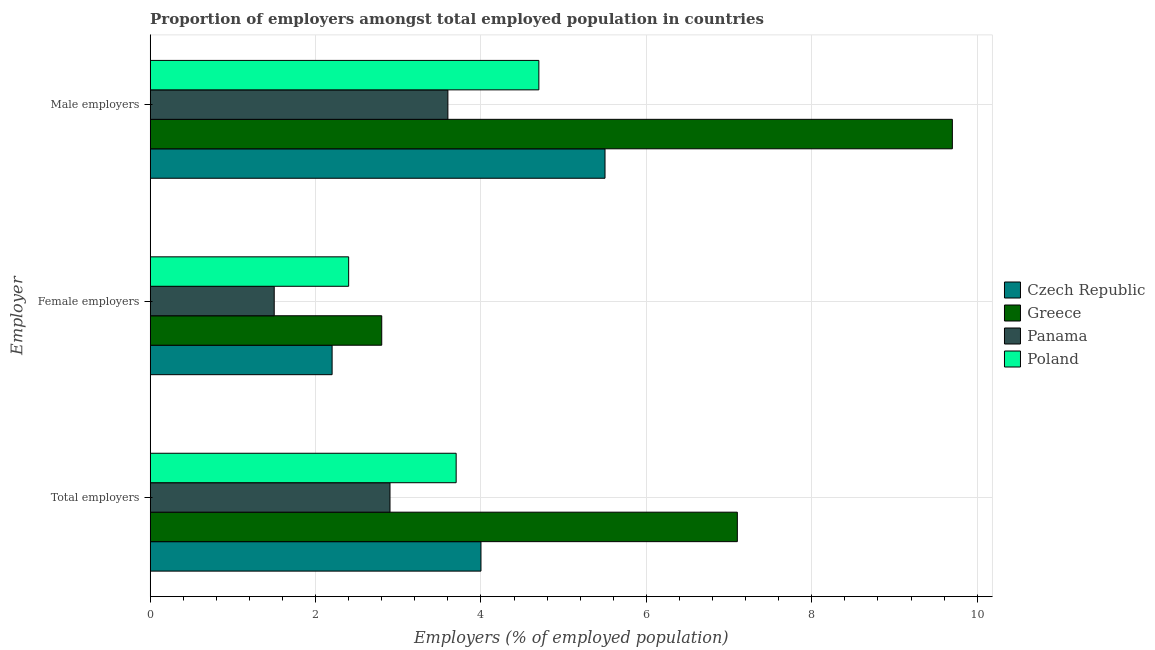How many different coloured bars are there?
Your answer should be compact. 4. How many groups of bars are there?
Make the answer very short. 3. Are the number of bars per tick equal to the number of legend labels?
Keep it short and to the point. Yes. Are the number of bars on each tick of the Y-axis equal?
Give a very brief answer. Yes. How many bars are there on the 3rd tick from the bottom?
Your answer should be very brief. 4. What is the label of the 2nd group of bars from the top?
Make the answer very short. Female employers. What is the percentage of female employers in Czech Republic?
Make the answer very short. 2.2. Across all countries, what is the maximum percentage of female employers?
Give a very brief answer. 2.8. In which country was the percentage of total employers minimum?
Give a very brief answer. Panama. What is the total percentage of total employers in the graph?
Ensure brevity in your answer.  17.7. What is the difference between the percentage of male employers in Greece and that in Czech Republic?
Make the answer very short. 4.2. What is the average percentage of total employers per country?
Keep it short and to the point. 4.43. What is the difference between the percentage of male employers and percentage of female employers in Poland?
Your answer should be compact. 2.3. In how many countries, is the percentage of total employers greater than 5.2 %?
Offer a terse response. 1. What is the ratio of the percentage of female employers in Greece to that in Panama?
Ensure brevity in your answer.  1.87. Is the difference between the percentage of female employers in Czech Republic and Greece greater than the difference between the percentage of total employers in Czech Republic and Greece?
Provide a succinct answer. Yes. What is the difference between the highest and the second highest percentage of female employers?
Keep it short and to the point. 0.4. What is the difference between the highest and the lowest percentage of female employers?
Your response must be concise. 1.3. Is the sum of the percentage of female employers in Poland and Czech Republic greater than the maximum percentage of male employers across all countries?
Provide a short and direct response. No. What does the 4th bar from the top in Total employers represents?
Keep it short and to the point. Czech Republic. What does the 3rd bar from the bottom in Female employers represents?
Your response must be concise. Panama. How many countries are there in the graph?
Your response must be concise. 4. What is the difference between two consecutive major ticks on the X-axis?
Keep it short and to the point. 2. Does the graph contain grids?
Offer a very short reply. Yes. Where does the legend appear in the graph?
Offer a very short reply. Center right. What is the title of the graph?
Offer a terse response. Proportion of employers amongst total employed population in countries. Does "Hong Kong" appear as one of the legend labels in the graph?
Make the answer very short. No. What is the label or title of the X-axis?
Keep it short and to the point. Employers (% of employed population). What is the label or title of the Y-axis?
Give a very brief answer. Employer. What is the Employers (% of employed population) in Greece in Total employers?
Offer a very short reply. 7.1. What is the Employers (% of employed population) in Panama in Total employers?
Your answer should be compact. 2.9. What is the Employers (% of employed population) in Poland in Total employers?
Give a very brief answer. 3.7. What is the Employers (% of employed population) in Czech Republic in Female employers?
Offer a terse response. 2.2. What is the Employers (% of employed population) of Greece in Female employers?
Ensure brevity in your answer.  2.8. What is the Employers (% of employed population) of Panama in Female employers?
Your answer should be very brief. 1.5. What is the Employers (% of employed population) of Poland in Female employers?
Make the answer very short. 2.4. What is the Employers (% of employed population) in Greece in Male employers?
Make the answer very short. 9.7. What is the Employers (% of employed population) of Panama in Male employers?
Your answer should be compact. 3.6. What is the Employers (% of employed population) in Poland in Male employers?
Provide a short and direct response. 4.7. Across all Employer, what is the maximum Employers (% of employed population) in Greece?
Keep it short and to the point. 9.7. Across all Employer, what is the maximum Employers (% of employed population) in Panama?
Offer a terse response. 3.6. Across all Employer, what is the maximum Employers (% of employed population) in Poland?
Give a very brief answer. 4.7. Across all Employer, what is the minimum Employers (% of employed population) in Czech Republic?
Provide a succinct answer. 2.2. Across all Employer, what is the minimum Employers (% of employed population) in Greece?
Your answer should be compact. 2.8. Across all Employer, what is the minimum Employers (% of employed population) of Panama?
Your response must be concise. 1.5. Across all Employer, what is the minimum Employers (% of employed population) in Poland?
Your response must be concise. 2.4. What is the total Employers (% of employed population) in Czech Republic in the graph?
Your response must be concise. 11.7. What is the total Employers (% of employed population) in Greece in the graph?
Keep it short and to the point. 19.6. What is the difference between the Employers (% of employed population) in Panama in Total employers and that in Female employers?
Provide a succinct answer. 1.4. What is the difference between the Employers (% of employed population) in Czech Republic in Total employers and that in Male employers?
Your answer should be very brief. -1.5. What is the difference between the Employers (% of employed population) of Panama in Total employers and that in Male employers?
Provide a short and direct response. -0.7. What is the difference between the Employers (% of employed population) of Czech Republic in Female employers and that in Male employers?
Offer a terse response. -3.3. What is the difference between the Employers (% of employed population) in Panama in Female employers and that in Male employers?
Make the answer very short. -2.1. What is the difference between the Employers (% of employed population) of Panama in Total employers and the Employers (% of employed population) of Poland in Female employers?
Provide a succinct answer. 0.5. What is the difference between the Employers (% of employed population) in Czech Republic in Total employers and the Employers (% of employed population) in Greece in Male employers?
Your response must be concise. -5.7. What is the difference between the Employers (% of employed population) of Czech Republic in Female employers and the Employers (% of employed population) of Greece in Male employers?
Offer a terse response. -7.5. What is the difference between the Employers (% of employed population) in Czech Republic in Female employers and the Employers (% of employed population) in Poland in Male employers?
Give a very brief answer. -2.5. What is the difference between the Employers (% of employed population) of Greece in Female employers and the Employers (% of employed population) of Panama in Male employers?
Provide a succinct answer. -0.8. What is the difference between the Employers (% of employed population) in Greece in Female employers and the Employers (% of employed population) in Poland in Male employers?
Your answer should be very brief. -1.9. What is the average Employers (% of employed population) of Greece per Employer?
Give a very brief answer. 6.53. What is the average Employers (% of employed population) of Panama per Employer?
Keep it short and to the point. 2.67. What is the difference between the Employers (% of employed population) of Czech Republic and Employers (% of employed population) of Greece in Total employers?
Your answer should be compact. -3.1. What is the difference between the Employers (% of employed population) of Czech Republic and Employers (% of employed population) of Poland in Total employers?
Keep it short and to the point. 0.3. What is the difference between the Employers (% of employed population) of Czech Republic and Employers (% of employed population) of Panama in Female employers?
Ensure brevity in your answer.  0.7. What is the difference between the Employers (% of employed population) of Czech Republic and Employers (% of employed population) of Poland in Female employers?
Your answer should be very brief. -0.2. What is the difference between the Employers (% of employed population) in Greece and Employers (% of employed population) in Panama in Female employers?
Your response must be concise. 1.3. What is the difference between the Employers (% of employed population) in Greece and Employers (% of employed population) in Poland in Female employers?
Your response must be concise. 0.4. What is the difference between the Employers (% of employed population) in Panama and Employers (% of employed population) in Poland in Female employers?
Offer a terse response. -0.9. What is the difference between the Employers (% of employed population) in Czech Republic and Employers (% of employed population) in Panama in Male employers?
Give a very brief answer. 1.9. What is the difference between the Employers (% of employed population) of Greece and Employers (% of employed population) of Panama in Male employers?
Keep it short and to the point. 6.1. What is the difference between the Employers (% of employed population) in Greece and Employers (% of employed population) in Poland in Male employers?
Provide a succinct answer. 5. What is the ratio of the Employers (% of employed population) in Czech Republic in Total employers to that in Female employers?
Make the answer very short. 1.82. What is the ratio of the Employers (% of employed population) in Greece in Total employers to that in Female employers?
Provide a succinct answer. 2.54. What is the ratio of the Employers (% of employed population) of Panama in Total employers to that in Female employers?
Offer a very short reply. 1.93. What is the ratio of the Employers (% of employed population) of Poland in Total employers to that in Female employers?
Offer a terse response. 1.54. What is the ratio of the Employers (% of employed population) in Czech Republic in Total employers to that in Male employers?
Your response must be concise. 0.73. What is the ratio of the Employers (% of employed population) of Greece in Total employers to that in Male employers?
Offer a very short reply. 0.73. What is the ratio of the Employers (% of employed population) in Panama in Total employers to that in Male employers?
Your answer should be very brief. 0.81. What is the ratio of the Employers (% of employed population) in Poland in Total employers to that in Male employers?
Your answer should be compact. 0.79. What is the ratio of the Employers (% of employed population) in Greece in Female employers to that in Male employers?
Provide a succinct answer. 0.29. What is the ratio of the Employers (% of employed population) in Panama in Female employers to that in Male employers?
Ensure brevity in your answer.  0.42. What is the ratio of the Employers (% of employed population) of Poland in Female employers to that in Male employers?
Your answer should be compact. 0.51. What is the difference between the highest and the second highest Employers (% of employed population) of Czech Republic?
Keep it short and to the point. 1.5. What is the difference between the highest and the second highest Employers (% of employed population) of Greece?
Make the answer very short. 2.6. What is the difference between the highest and the second highest Employers (% of employed population) in Panama?
Give a very brief answer. 0.7. What is the difference between the highest and the lowest Employers (% of employed population) in Czech Republic?
Give a very brief answer. 3.3. What is the difference between the highest and the lowest Employers (% of employed population) in Poland?
Your answer should be compact. 2.3. 